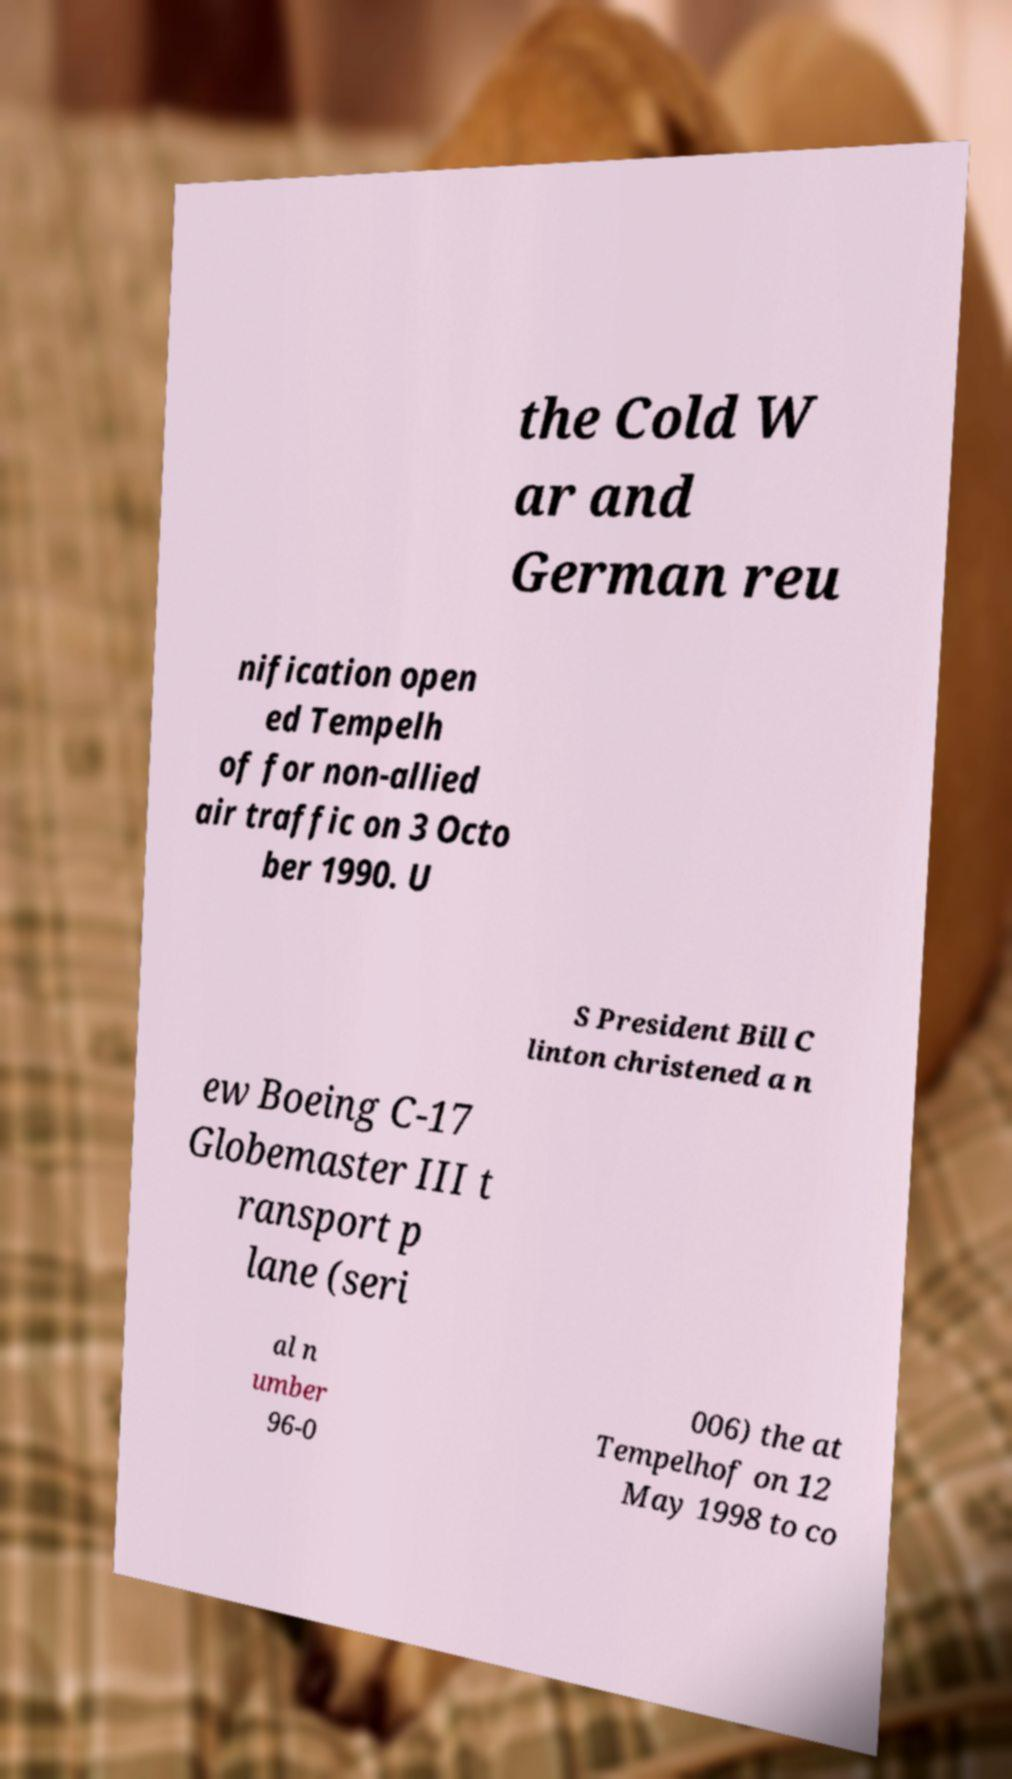Could you extract and type out the text from this image? the Cold W ar and German reu nification open ed Tempelh of for non-allied air traffic on 3 Octo ber 1990. U S President Bill C linton christened a n ew Boeing C-17 Globemaster III t ransport p lane (seri al n umber 96-0 006) the at Tempelhof on 12 May 1998 to co 